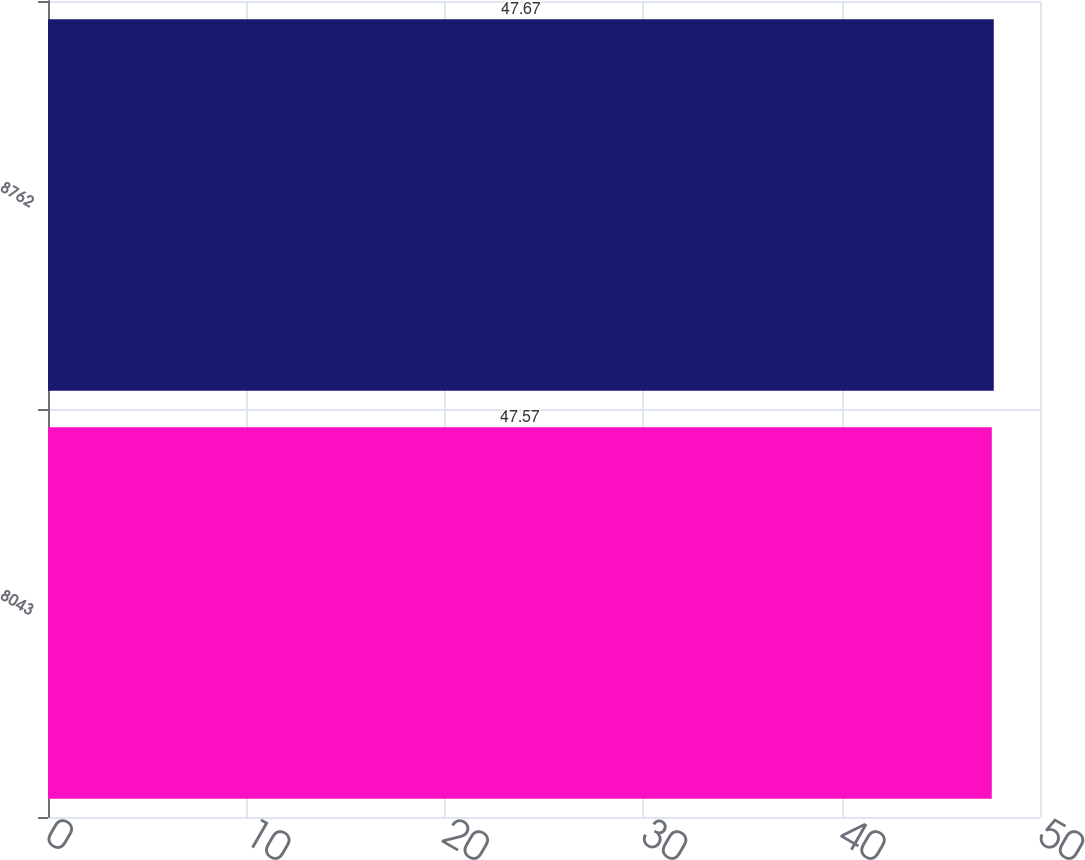<chart> <loc_0><loc_0><loc_500><loc_500><bar_chart><fcel>8043<fcel>8762<nl><fcel>47.57<fcel>47.67<nl></chart> 